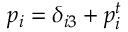Convert formula to latex. <formula><loc_0><loc_0><loc_500><loc_500>p _ { i } = \delta _ { i 3 } + p _ { i } ^ { t }</formula> 